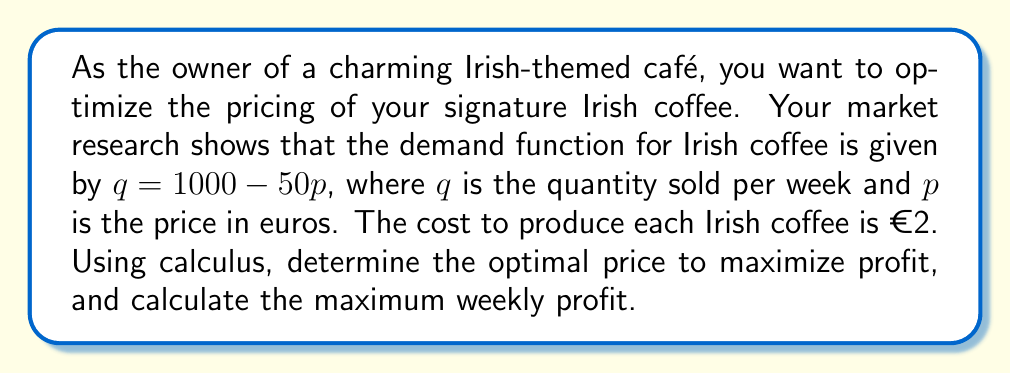Show me your answer to this math problem. Let's approach this step-by-step using calculus:

1) First, we need to formulate the profit function. Profit is revenue minus cost.

   Revenue = $pq = p(1000 - 50p) = 1000p - 50p^2$
   Cost = $2q = 2(1000 - 50p) = 2000 - 100p$
   
   Profit function: $\pi(p) = (1000p - 50p^2) - (2000 - 100p)$
                            $= 1000p - 50p^2 - 2000 + 100p$
                            $= 1100p - 50p^2 - 2000$

2) To find the maximum profit, we need to find where the derivative of the profit function equals zero:

   $\frac{d\pi}{dp} = 1100 - 100p$

3) Set this equal to zero and solve for p:

   $1100 - 100p = 0$
   $-100p = -1100$
   $p = 11$

4) To confirm this is a maximum (not a minimum), check the second derivative:

   $\frac{d^2\pi}{dp^2} = -100$

   Since this is negative, we confirm that $p = 11$ gives a maximum.

5) The optimal price is therefore €11.

6) To find the maximum profit, we substitute this price back into our profit function:

   $\pi(11) = 1100(11) - 50(11)^2 - 2000$
             $= 12100 - 6050 - 2000$
             $= 4050$

Therefore, the maximum weekly profit is €4050.
Answer: The optimal price for Irish coffee is €11, which will result in a maximum weekly profit of €4050. 